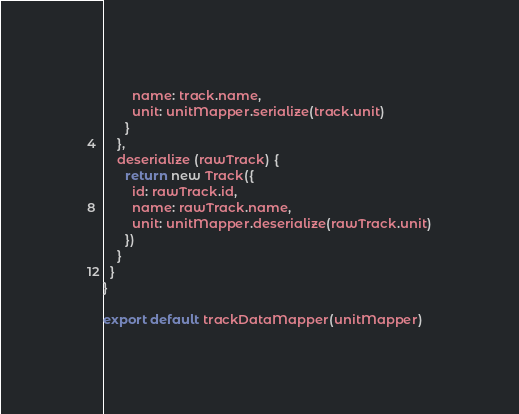<code> <loc_0><loc_0><loc_500><loc_500><_JavaScript_>        name: track.name,
        unit: unitMapper.serialize(track.unit)
      }
    },
    deserialize (rawTrack) {
      return new Track({
        id: rawTrack.id,
        name: rawTrack.name,
        unit: unitMapper.deserialize(rawTrack.unit)
      })
    }
  }
}

export default trackDataMapper(unitMapper)
</code> 